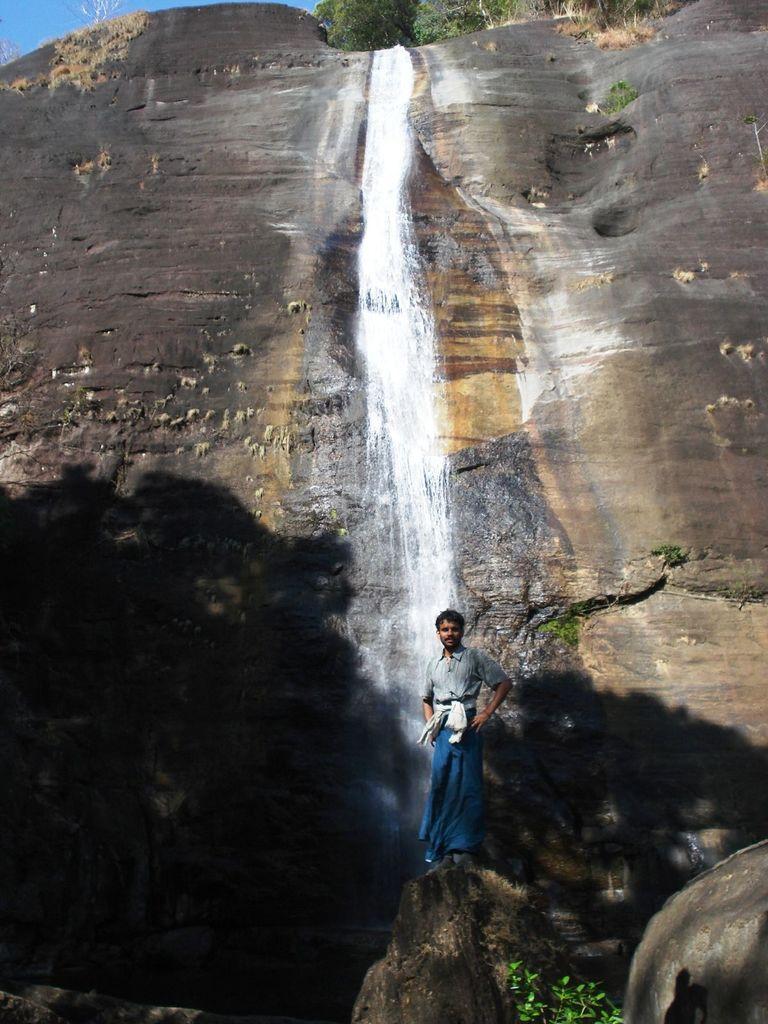Describe this image in one or two sentences. In this image I can see a waterfall falling from the mountain. A person is standing on a stone in front of the waterfall and we can see small plants at the bottom and trees at the top of the image. 